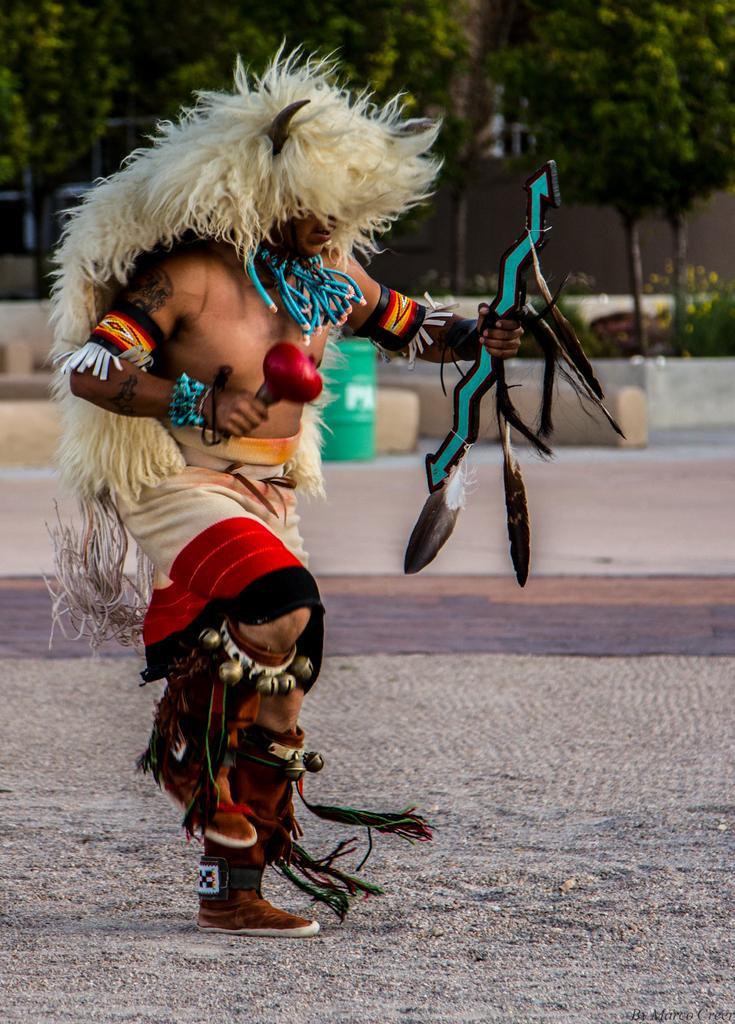Can you describe this image briefly? In the middle of the image a man is standing and holding something. Behind him there are some trees and plants and walls. Behind the trees there are some buildings. 